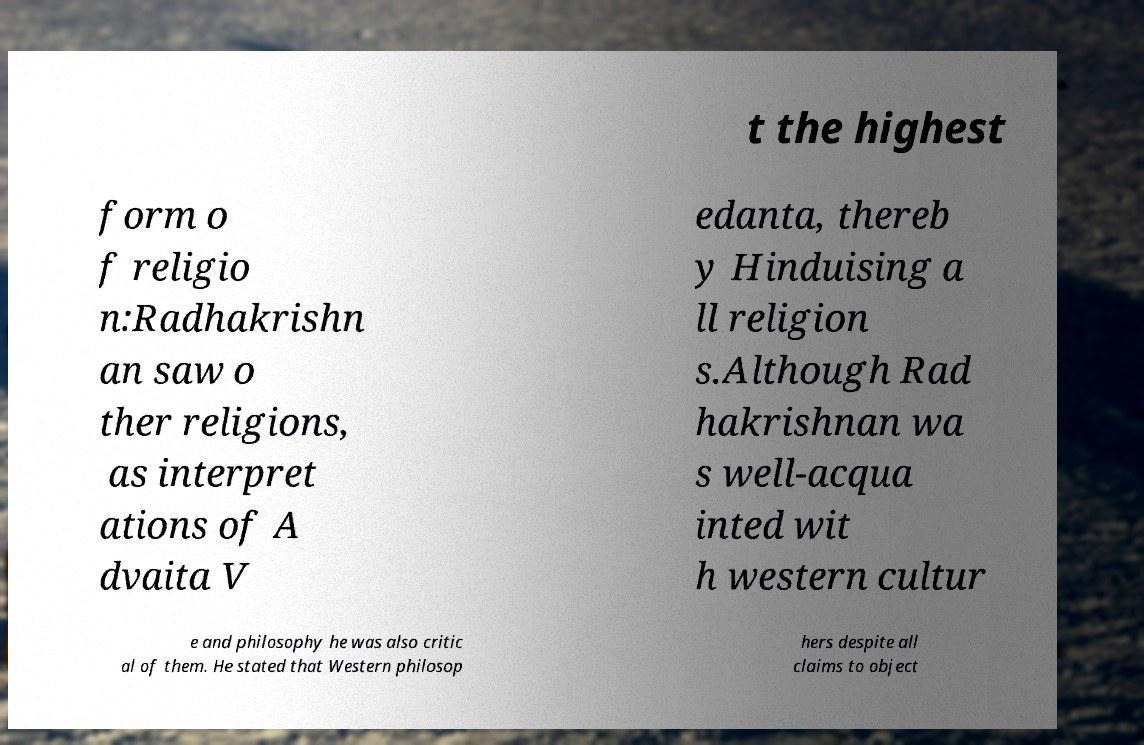Could you assist in decoding the text presented in this image and type it out clearly? t the highest form o f religio n:Radhakrishn an saw o ther religions, as interpret ations of A dvaita V edanta, thereb y Hinduising a ll religion s.Although Rad hakrishnan wa s well-acqua inted wit h western cultur e and philosophy he was also critic al of them. He stated that Western philosop hers despite all claims to object 